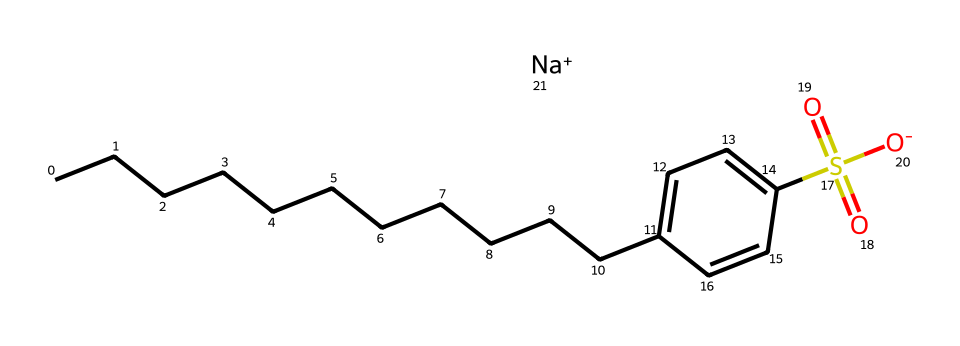what is the structural feature indicating the presence of a sulfonate group? The chemical structure includes a sulfur atom bonded to three oxygen atoms, where one of the oxygens carries a negative charge. This arrangement is characteristic of sulfonate groups.
Answer: sulfonate group how many carbon atoms are in sodium dodecylbenzene sulfonate? The structure shows a long hydrocarbon chain with twelve carbon atoms in the dodecyl part (CCCCCCCCCCCC) along with another carbon in the benzene ring, for a total of thirteen carbon atoms.
Answer: thirteen what characterizes this compound as an anionic surfactant? The presence of a negatively charged sulfonate group, along with a long hydrophobic alkyl chain, classifies this compound as an anionic surfactant, which is common in detergents.
Answer: negatively charged sulfonate group how many hydrogen atoms are likely present in the molecule? The hydrocarbon chain and the benzene ring are fully saturated with hydrogen atoms, but due to the ionic nature of the sulfonate and structural bonding, the exact number may vary. However, counting overall, there are approximately 22 hydrogen atoms.
Answer: twenty-two what is the role of sodium in this compound? Sodium acts as a counterion balancing the negative charge from the sulfonate group, which allows the compound to maintain its stability in solution and enhances its surfactant properties.
Answer: counterion why is sodium dodecylbenzene sulfonate effective for cleaning medical equipment? Its long hydrophobic alkyl chain helps to solubilize and emulsify oils and dirt, while the hydrophilic sulfonate group allows it to interact with water, facilitating the removal of contaminants from surfaces.
Answer: solubilizes and emulsifies 